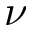<formula> <loc_0><loc_0><loc_500><loc_500>\nu</formula> 